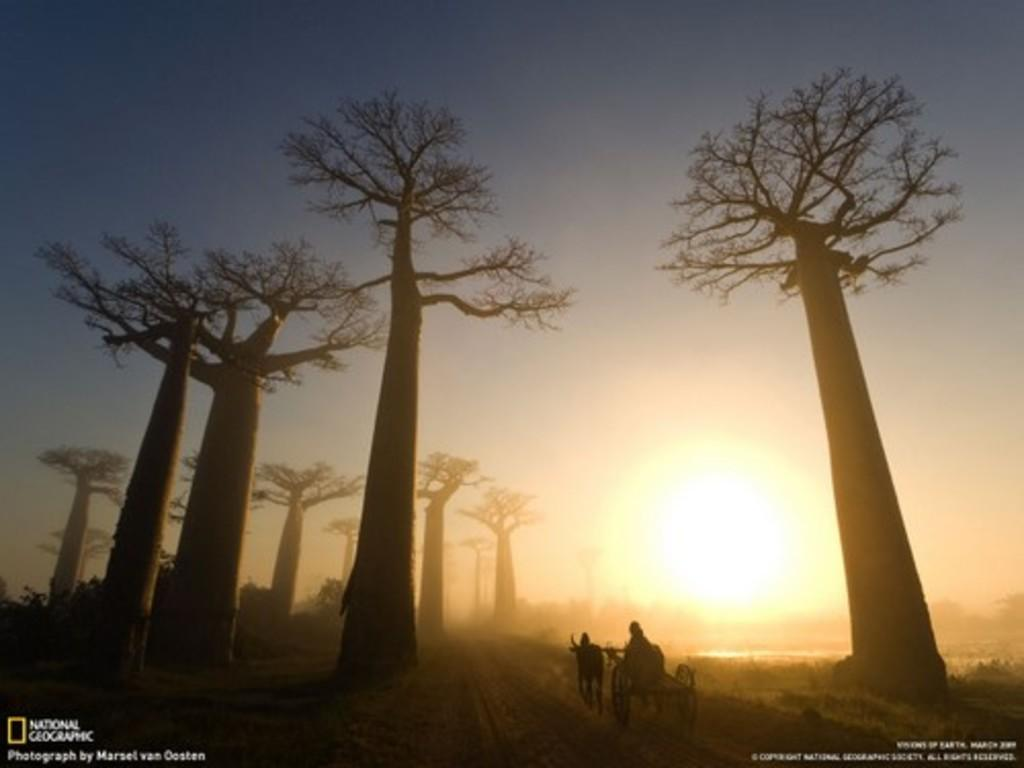What type of vegetation can be seen in the image? There are trees in the image. What mode of transportation is the person using? There is a person on a bullock cart in the image. What is at the bottom of the image? There is a road at the bottom of the image. What else can be seen in the image besides the trees and the person on the bullock cart? There is text visible in the image. What can be seen in the background of the image? The sun is visible in the background of the image. What type of record is being played on the bullock cart in the image? There is no record or music player visible in the image; it features a person on a bullock cart, trees, a road, text, and the sun in the background. What verse is being recited by the trees in the image? There are no verses or recitations associated with the trees in the image; they are simply depicted as vegetation. 